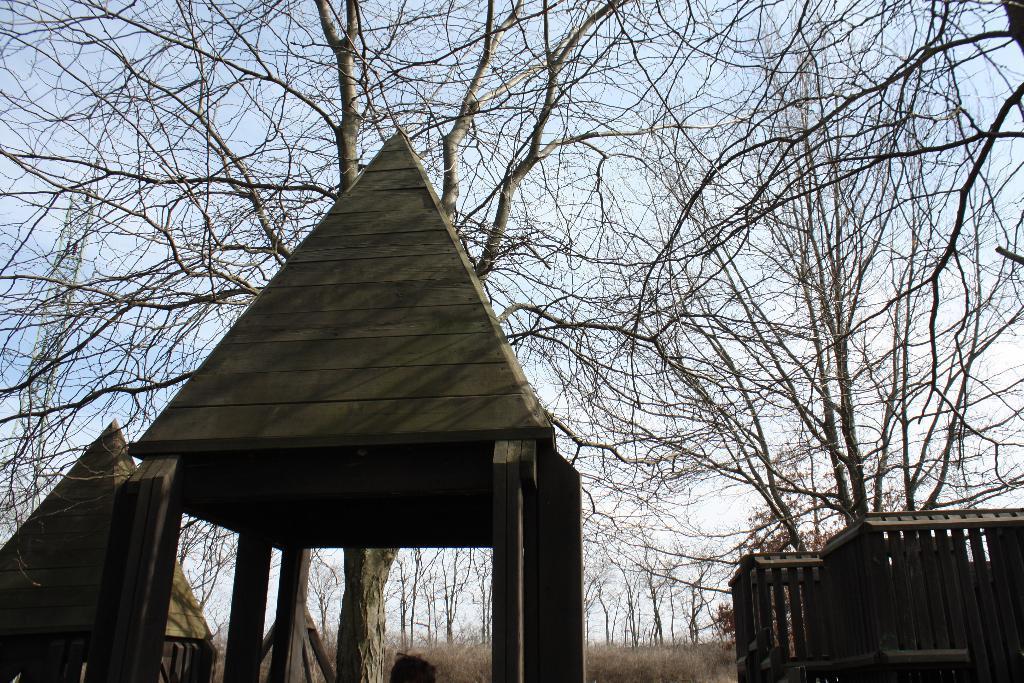Can you describe this image briefly? This picture consists of tent houses and trees and the sky and grass visible 